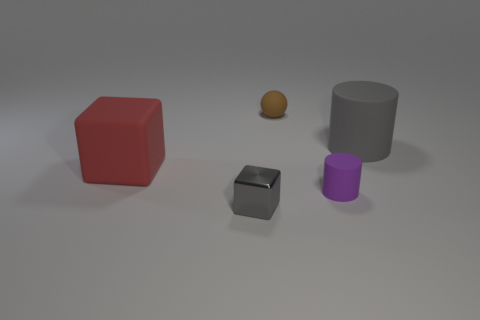Add 5 tiny purple things. How many objects exist? 10 Add 2 balls. How many balls are left? 3 Add 1 tiny red matte things. How many tiny red matte things exist? 1 Subtract 0 brown cylinders. How many objects are left? 5 Subtract all spheres. How many objects are left? 4 Subtract all gray rubber things. Subtract all big red objects. How many objects are left? 3 